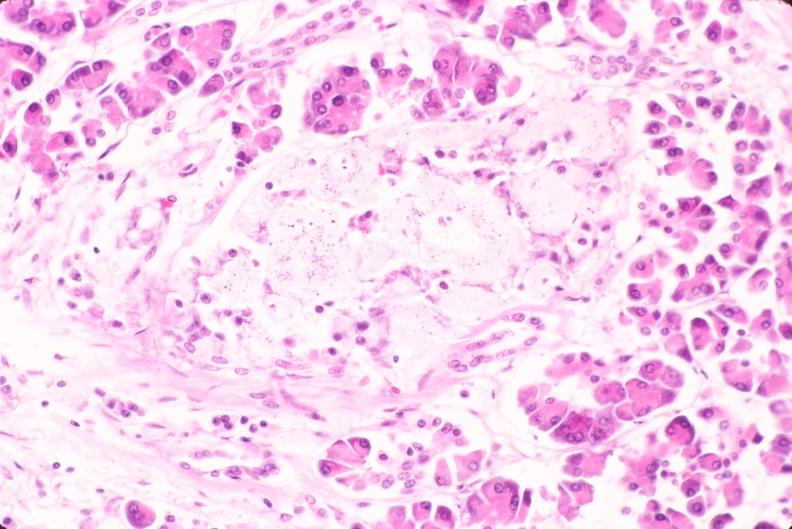s endocrine present?
Answer the question using a single word or phrase. Yes 